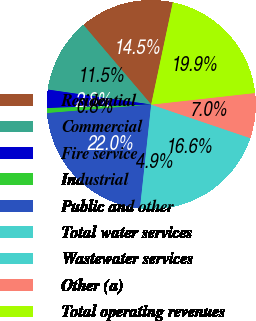Convert chart to OTSL. <chart><loc_0><loc_0><loc_500><loc_500><pie_chart><fcel>Residential<fcel>Commercial<fcel>Fire service<fcel>Industrial<fcel>Public and other<fcel>Total water services<fcel>Wastewater services<fcel>Other (a)<fcel>Total operating revenues<nl><fcel>14.55%<fcel>11.49%<fcel>2.83%<fcel>0.77%<fcel>21.98%<fcel>4.9%<fcel>16.62%<fcel>6.97%<fcel>19.91%<nl></chart> 